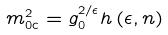Convert formula to latex. <formula><loc_0><loc_0><loc_500><loc_500>m _ { 0 \text {c} } ^ { 2 } = g _ { 0 } ^ { 2 / \epsilon } h \left ( \epsilon , n \right )</formula> 